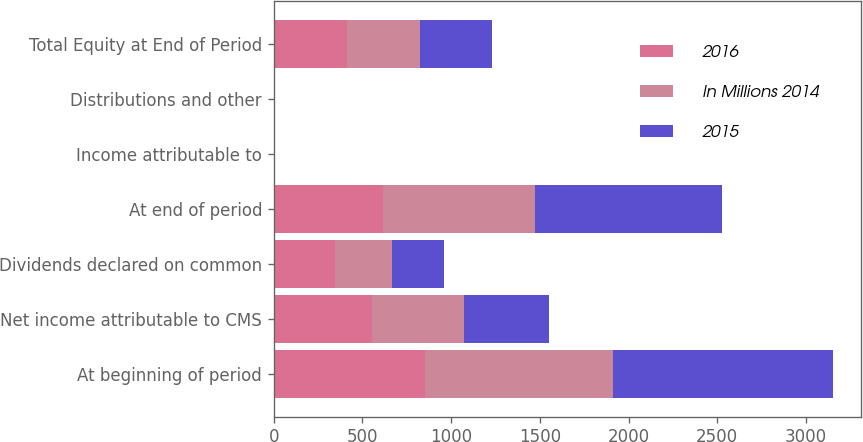<chart> <loc_0><loc_0><loc_500><loc_500><stacked_bar_chart><ecel><fcel>At beginning of period<fcel>Net income attributable to CMS<fcel>Dividends declared on common<fcel>At end of period<fcel>Income attributable to<fcel>Distributions and other<fcel>Total Equity at End of Period<nl><fcel>2016<fcel>855<fcel>551<fcel>345<fcel>616<fcel>2<fcel>2<fcel>411<nl><fcel>In Millions 2014<fcel>1058<fcel>523<fcel>320<fcel>855<fcel>2<fcel>2<fcel>411<nl><fcel>2015<fcel>1242<fcel>477<fcel>293<fcel>1058<fcel>2<fcel>2<fcel>411<nl></chart> 